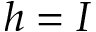<formula> <loc_0><loc_0><loc_500><loc_500>h = I</formula> 